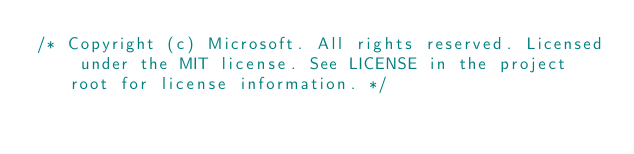<code> <loc_0><loc_0><loc_500><loc_500><_CSS_>/* Copyright (c) Microsoft. All rights reserved. Licensed under the MIT license. See LICENSE in the project root for license information. */</code> 